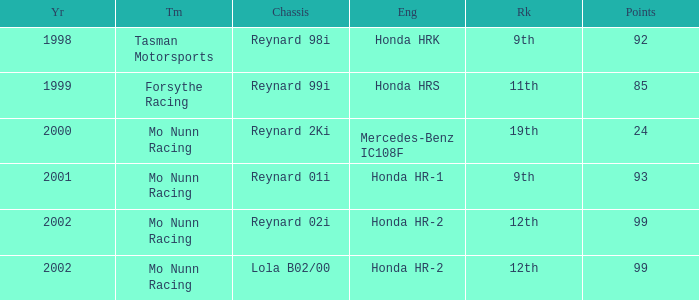What is the total number of points of the honda hr-1 engine? 1.0. 